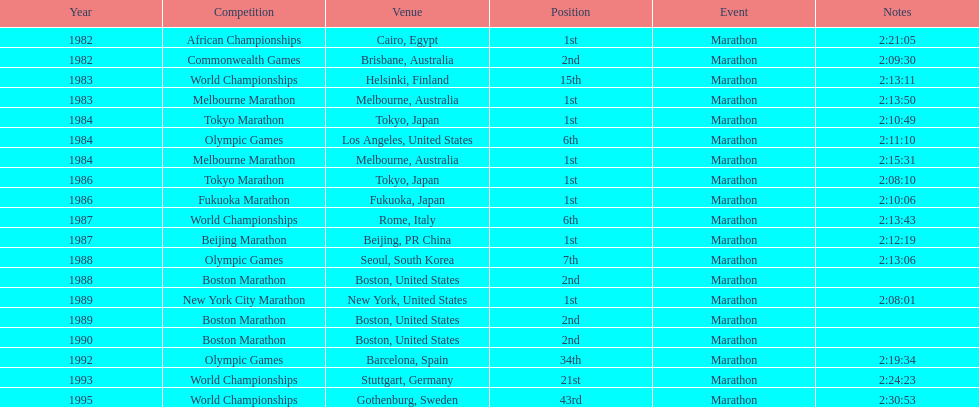What are the total number of times the position of 1st place was earned? 8. 